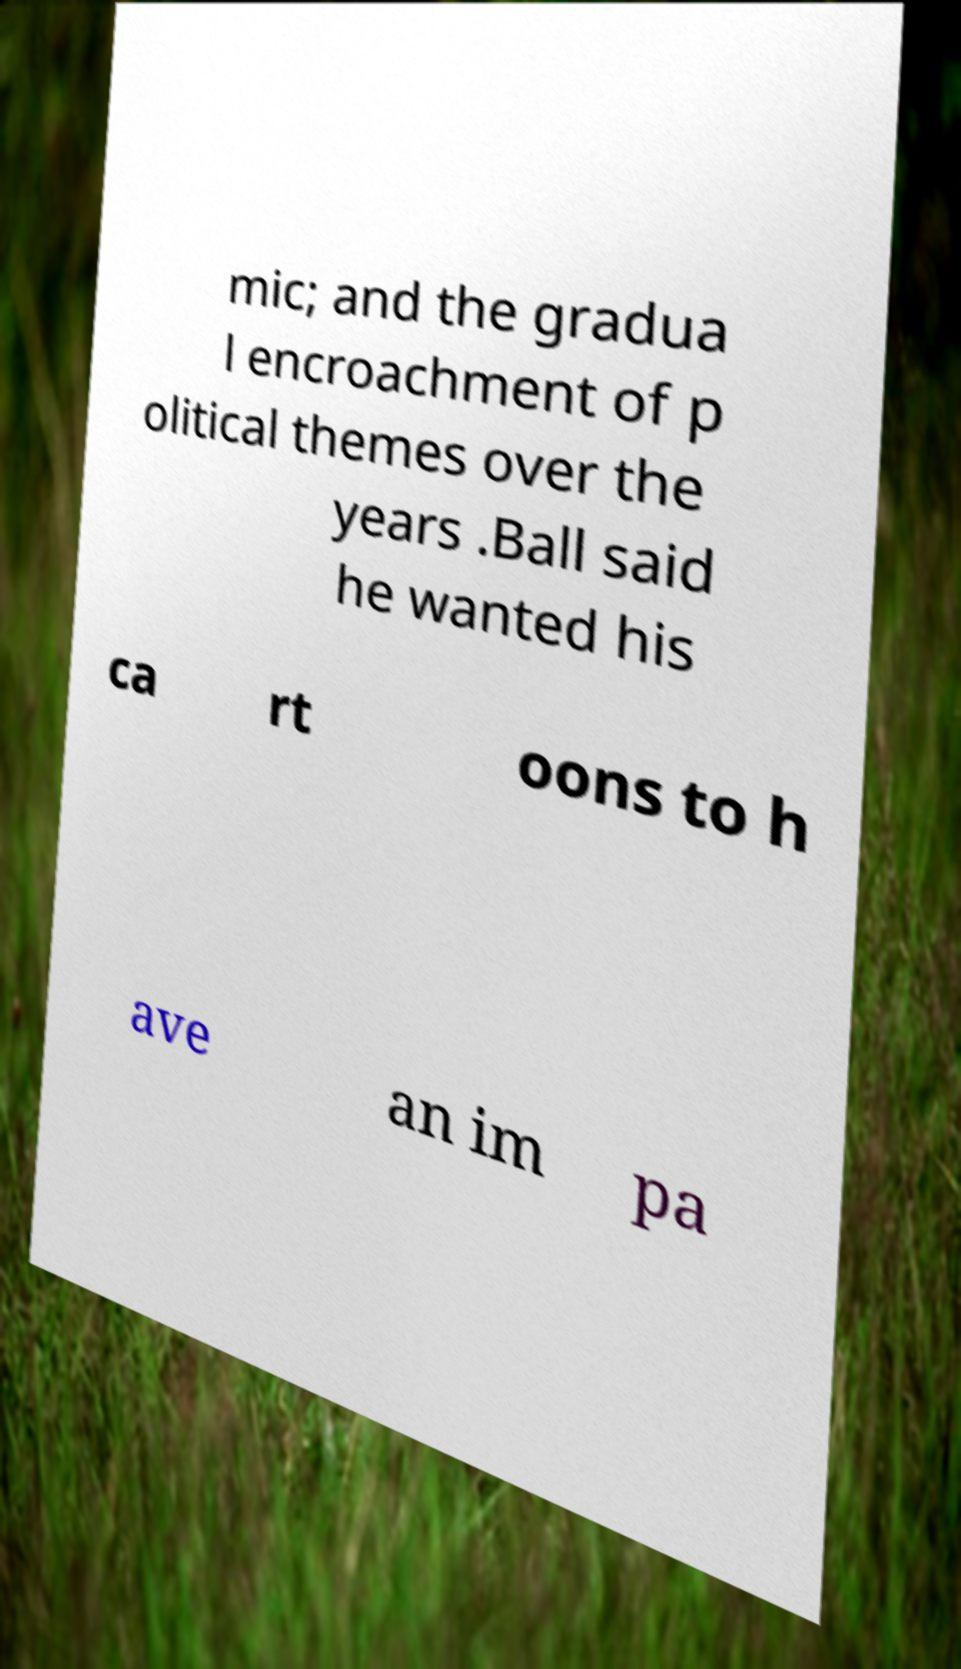For documentation purposes, I need the text within this image transcribed. Could you provide that? mic; and the gradua l encroachment of p olitical themes over the years .Ball said he wanted his ca rt oons to h ave an im pa 